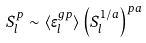<formula> <loc_0><loc_0><loc_500><loc_500>S _ { l } ^ { p } \sim \langle \epsilon ^ { g p } _ { l } \rangle \left ( S _ { l } ^ { 1 / a } \right ) ^ { p a }</formula> 